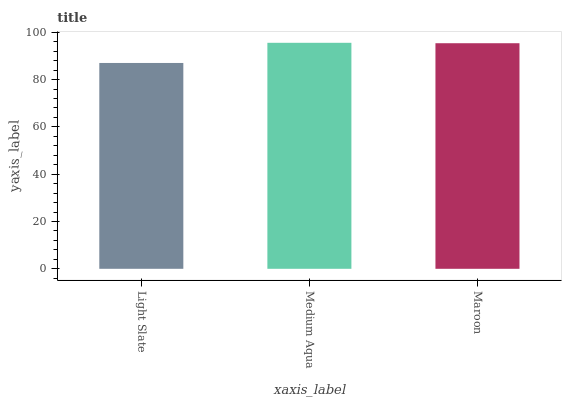Is Maroon the minimum?
Answer yes or no. No. Is Maroon the maximum?
Answer yes or no. No. Is Medium Aqua greater than Maroon?
Answer yes or no. Yes. Is Maroon less than Medium Aqua?
Answer yes or no. Yes. Is Maroon greater than Medium Aqua?
Answer yes or no. No. Is Medium Aqua less than Maroon?
Answer yes or no. No. Is Maroon the high median?
Answer yes or no. Yes. Is Maroon the low median?
Answer yes or no. Yes. Is Light Slate the high median?
Answer yes or no. No. Is Medium Aqua the low median?
Answer yes or no. No. 